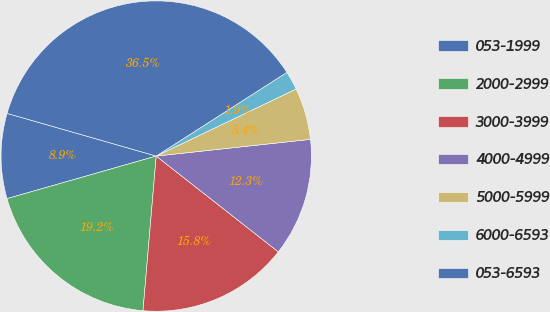Convert chart to OTSL. <chart><loc_0><loc_0><loc_500><loc_500><pie_chart><fcel>053-1999<fcel>2000-2999<fcel>3000-3999<fcel>4000-4999<fcel>5000-5999<fcel>6000-6593<fcel>053-6593<nl><fcel>8.86%<fcel>19.22%<fcel>15.77%<fcel>12.31%<fcel>5.4%<fcel>1.95%<fcel>36.5%<nl></chart> 